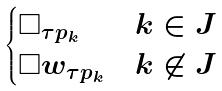<formula> <loc_0><loc_0><loc_500><loc_500>\begin{cases} \Box _ { \tau p _ { k } } & k \in J \\ \Box w _ { \tau p _ { k } } & k \not \in J \end{cases}</formula> 